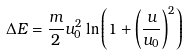Convert formula to latex. <formula><loc_0><loc_0><loc_500><loc_500>\Delta E = \frac { m } { 2 } u _ { 0 } ^ { 2 } \ln { \left ( 1 + \left ( \frac { u } { u _ { 0 } } \right ) ^ { 2 } \right ) }</formula> 